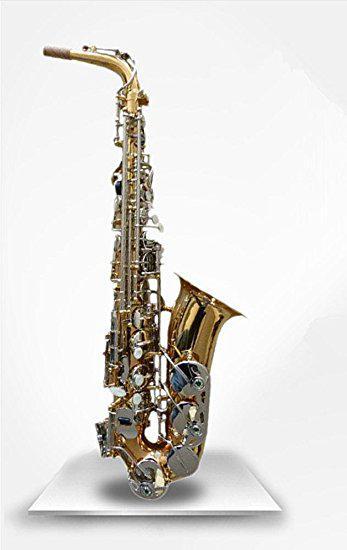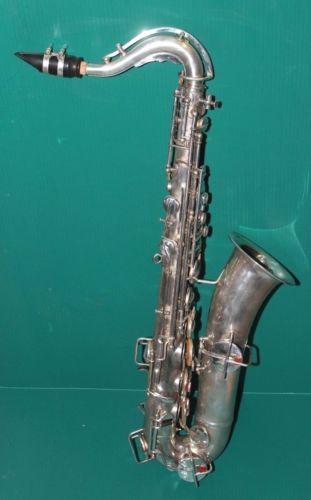The first image is the image on the left, the second image is the image on the right. Evaluate the accuracy of this statement regarding the images: "There are no more than 3 saxophones.". Is it true? Answer yes or no. Yes. The first image is the image on the left, the second image is the image on the right. Analyze the images presented: Is the assertion "There are more than four saxophones in total." valid? Answer yes or no. No. 